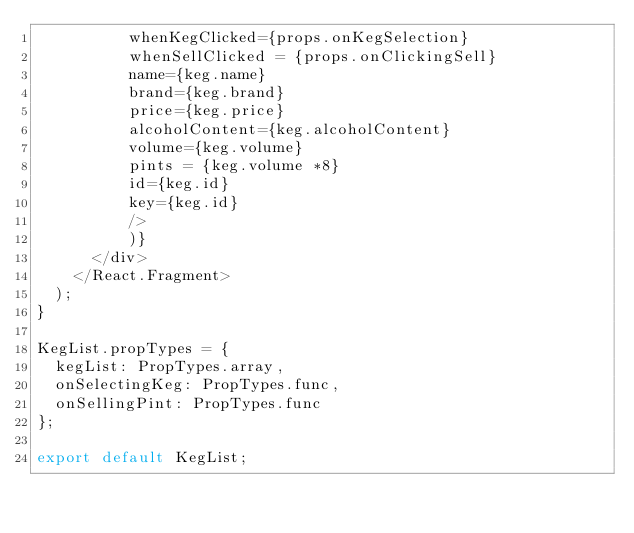Convert code to text. <code><loc_0><loc_0><loc_500><loc_500><_JavaScript_>          whenKegClicked={props.onKegSelection}
          whenSellClicked = {props.onClickingSell}
          name={keg.name}
          brand={keg.brand}
          price={keg.price}
          alcoholContent={keg.alcoholContent}
          volume={keg.volume}
          pints = {keg.volume *8}
          id={keg.id}
          key={keg.id}
          />
          )}
      </div>
    </React.Fragment>
  );
}

KegList.propTypes = {
  kegList: PropTypes.array,
  onSelectingKeg: PropTypes.func,
  onSellingPint: PropTypes.func
};

export default KegList;</code> 